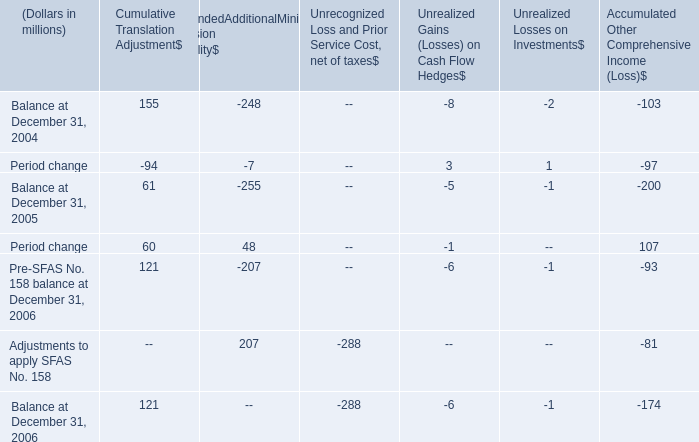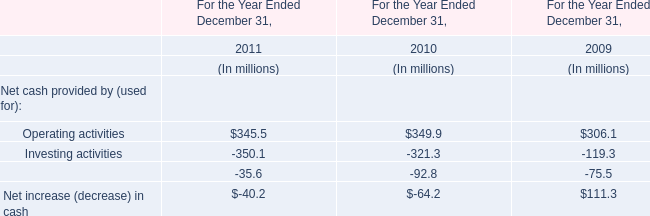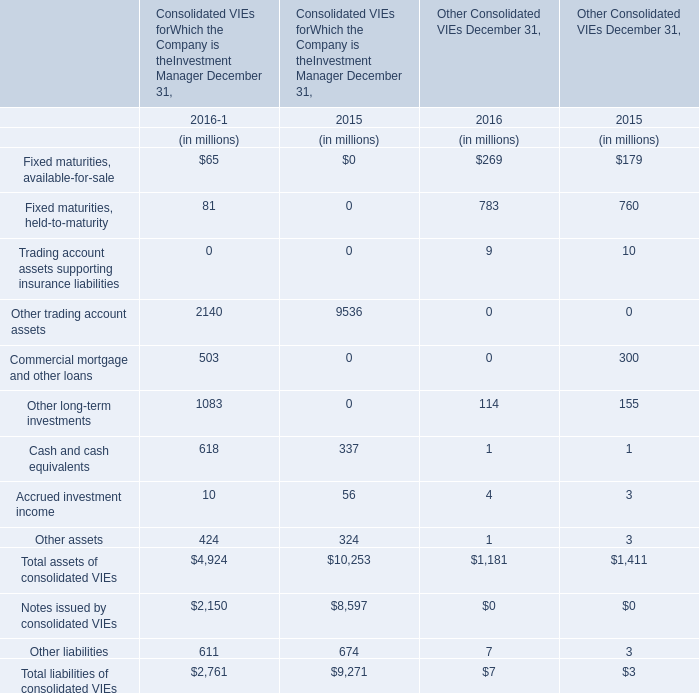At December 31,what year is Other assets in terms of Other Consolidated VIEs higher? 
Answer: 2015. 